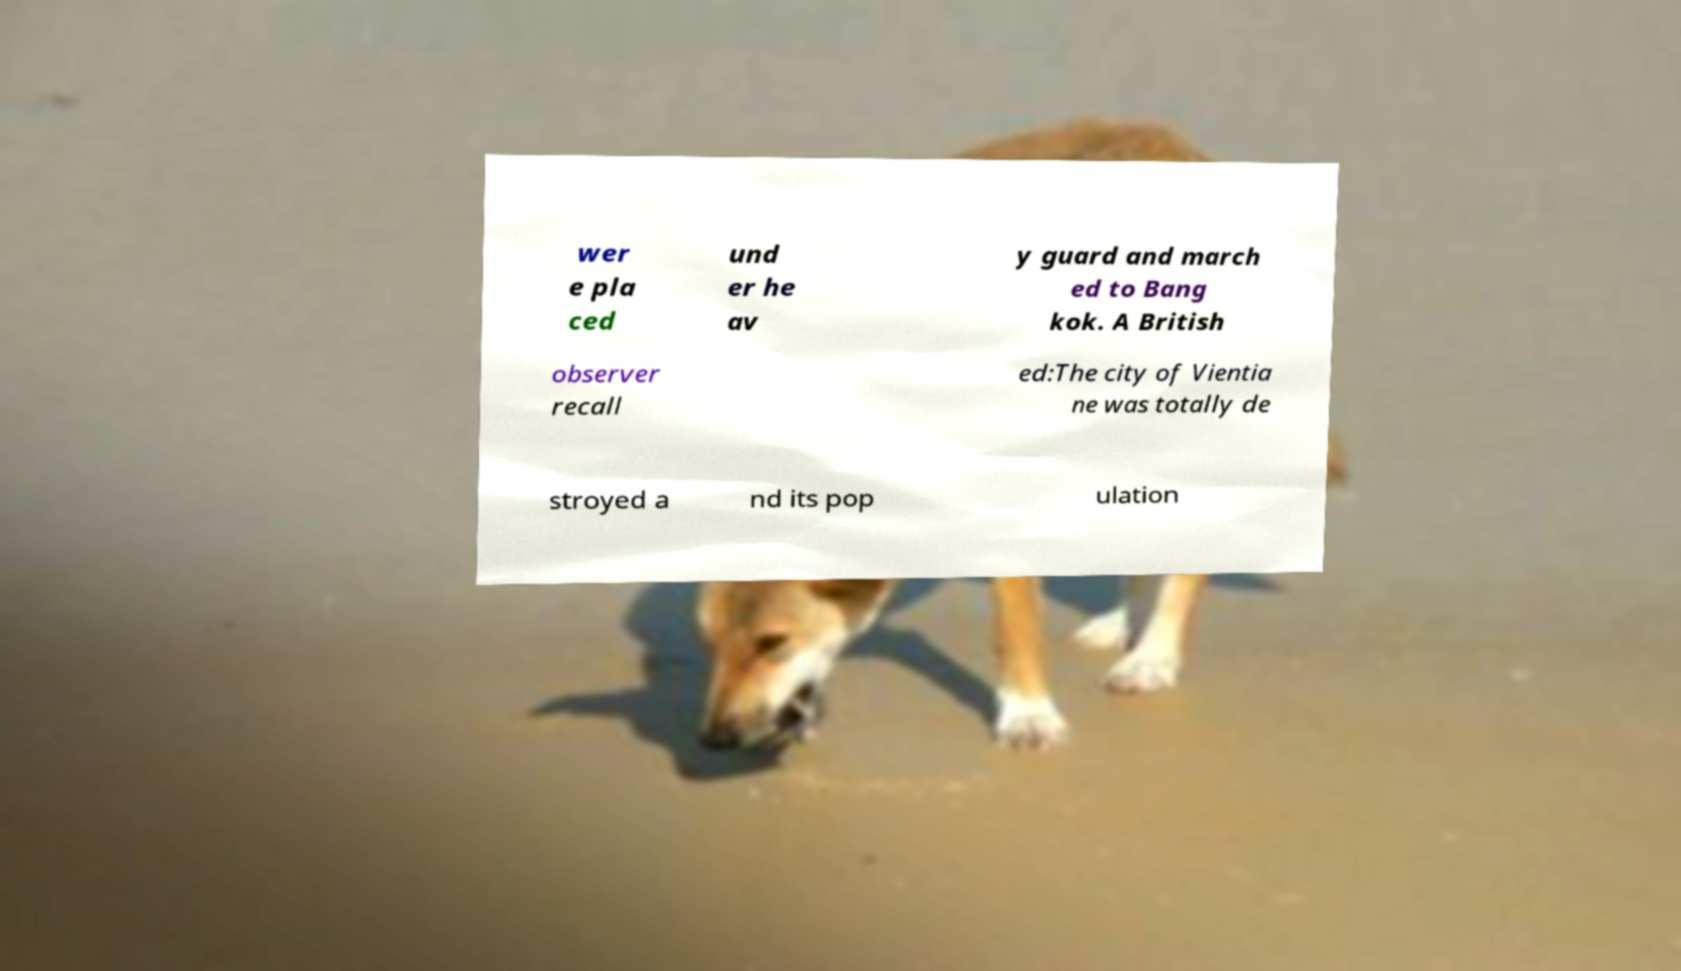Please read and relay the text visible in this image. What does it say? wer e pla ced und er he av y guard and march ed to Bang kok. A British observer recall ed:The city of Vientia ne was totally de stroyed a nd its pop ulation 